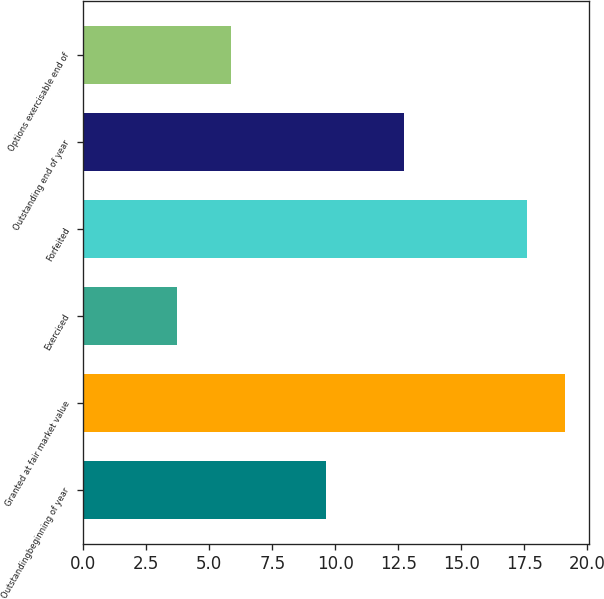<chart> <loc_0><loc_0><loc_500><loc_500><bar_chart><fcel>Outstandingbeginning of year<fcel>Granted at fair market value<fcel>Exercised<fcel>Forfeited<fcel>Outstanding end of year<fcel>Options exercisable end of<nl><fcel>9.63<fcel>19.12<fcel>3.72<fcel>17.59<fcel>12.71<fcel>5.85<nl></chart> 